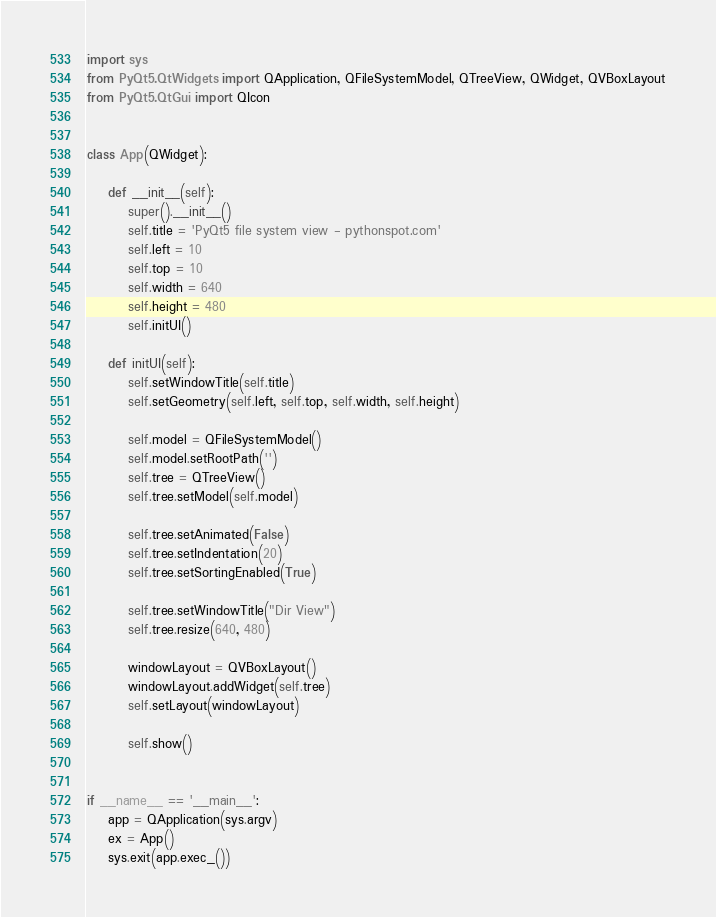Convert code to text. <code><loc_0><loc_0><loc_500><loc_500><_Python_>import sys
from PyQt5.QtWidgets import QApplication, QFileSystemModel, QTreeView, QWidget, QVBoxLayout
from PyQt5.QtGui import QIcon


class App(QWidget):

    def __init__(self):
        super().__init__()
        self.title = 'PyQt5 file system view - pythonspot.com'
        self.left = 10
        self.top = 10
        self.width = 640
        self.height = 480
        self.initUI()

    def initUI(self):
        self.setWindowTitle(self.title)
        self.setGeometry(self.left, self.top, self.width, self.height)

        self.model = QFileSystemModel()
        self.model.setRootPath('')
        self.tree = QTreeView()
        self.tree.setModel(self.model)

        self.tree.setAnimated(False)
        self.tree.setIndentation(20)
        self.tree.setSortingEnabled(True)

        self.tree.setWindowTitle("Dir View")
        self.tree.resize(640, 480)

        windowLayout = QVBoxLayout()
        windowLayout.addWidget(self.tree)
        self.setLayout(windowLayout)

        self.show()


if __name__ == '__main__':
    app = QApplication(sys.argv)
    ex = App()
    sys.exit(app.exec_())</code> 